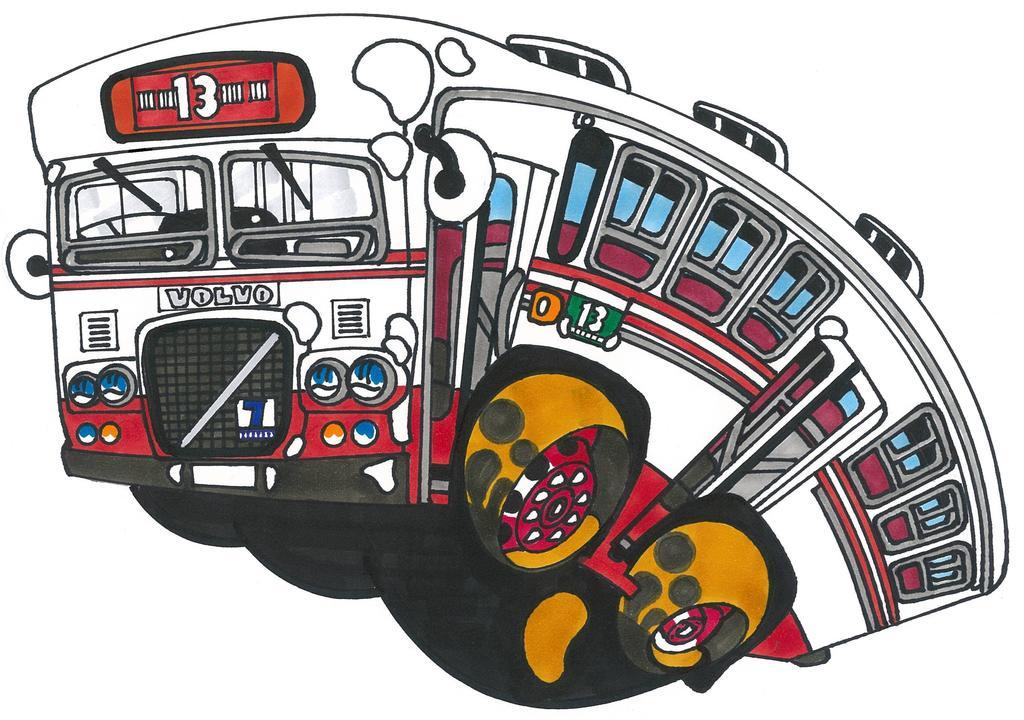What is the main subject of the image? The main subject of the image is a cartoon of a bus. What features can be seen on the bus? The bus has windows and doors. Is there any text or writing on the bus? Yes, there is text or writing on the bus. What is the color of the background in the image? The background of the image is white. What type of fuel is the bus using in the image? The image is a cartoon, and there is no information about the type of fuel the bus is using. Can you see any trains in the image? No, there are no trains present in the image; it only features a cartoon bus. 